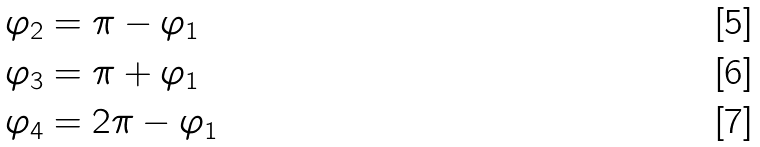Convert formula to latex. <formula><loc_0><loc_0><loc_500><loc_500>\varphi _ { 2 } & = \pi - \varphi _ { 1 } \\ \varphi _ { 3 } & = \pi + \varphi _ { 1 } \\ \varphi _ { 4 } & = 2 \pi - \varphi _ { 1 }</formula> 